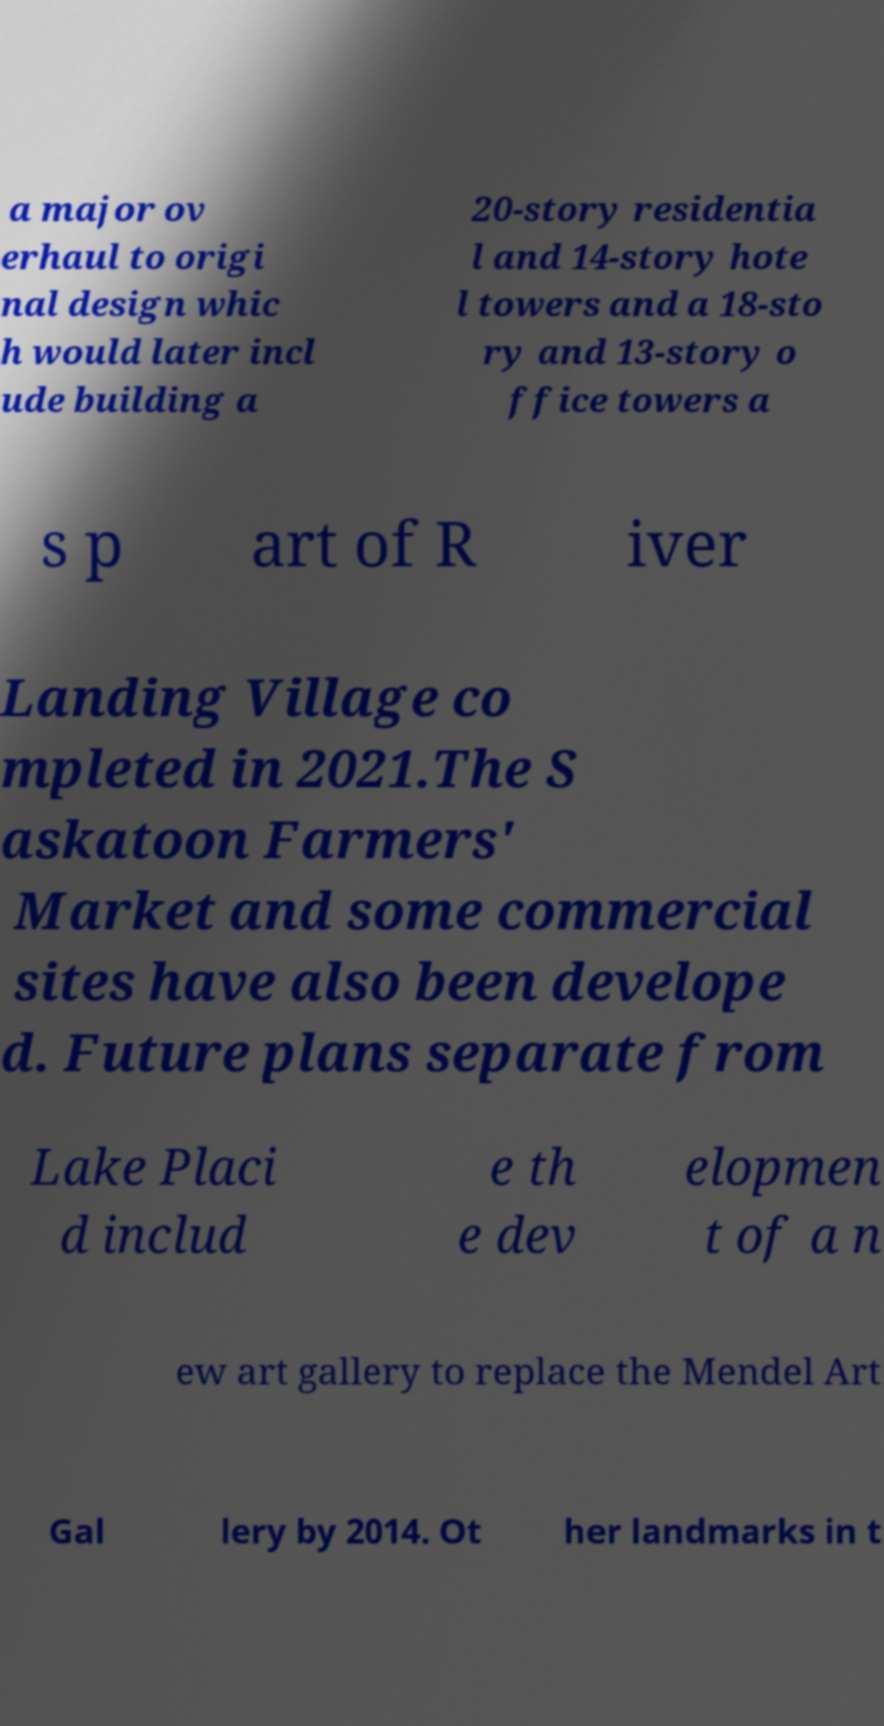There's text embedded in this image that I need extracted. Can you transcribe it verbatim? a major ov erhaul to origi nal design whic h would later incl ude building a 20-story residentia l and 14-story hote l towers and a 18-sto ry and 13-story o ffice towers a s p art of R iver Landing Village co mpleted in 2021.The S askatoon Farmers' Market and some commercial sites have also been develope d. Future plans separate from Lake Placi d includ e th e dev elopmen t of a n ew art gallery to replace the Mendel Art Gal lery by 2014. Ot her landmarks in t 